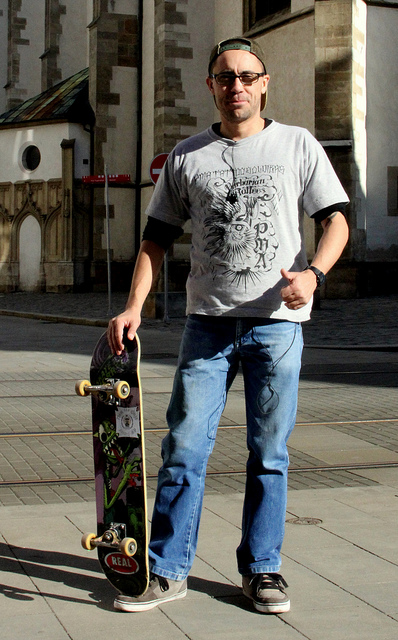<image>What is the name of the brown store pictured in the upper portion of this scene? I don't know the name of the brown store pictured in the upper portion of this scene. What is holding up the brick on the right side of the boy? I don't know what is holding up the brick on the right side of the boy. It could be anything from the ground, cement, building, a wall, street, column or hand. What is the name of the brown store pictured in the upper portion of this scene? I don't know the name of the brown store pictured in the upper portion of this scene. What is holding up the brick on the right side of the boy? I don't know what is holding up the brick on the right side of the boy. It can be nothing, hand or something else. 